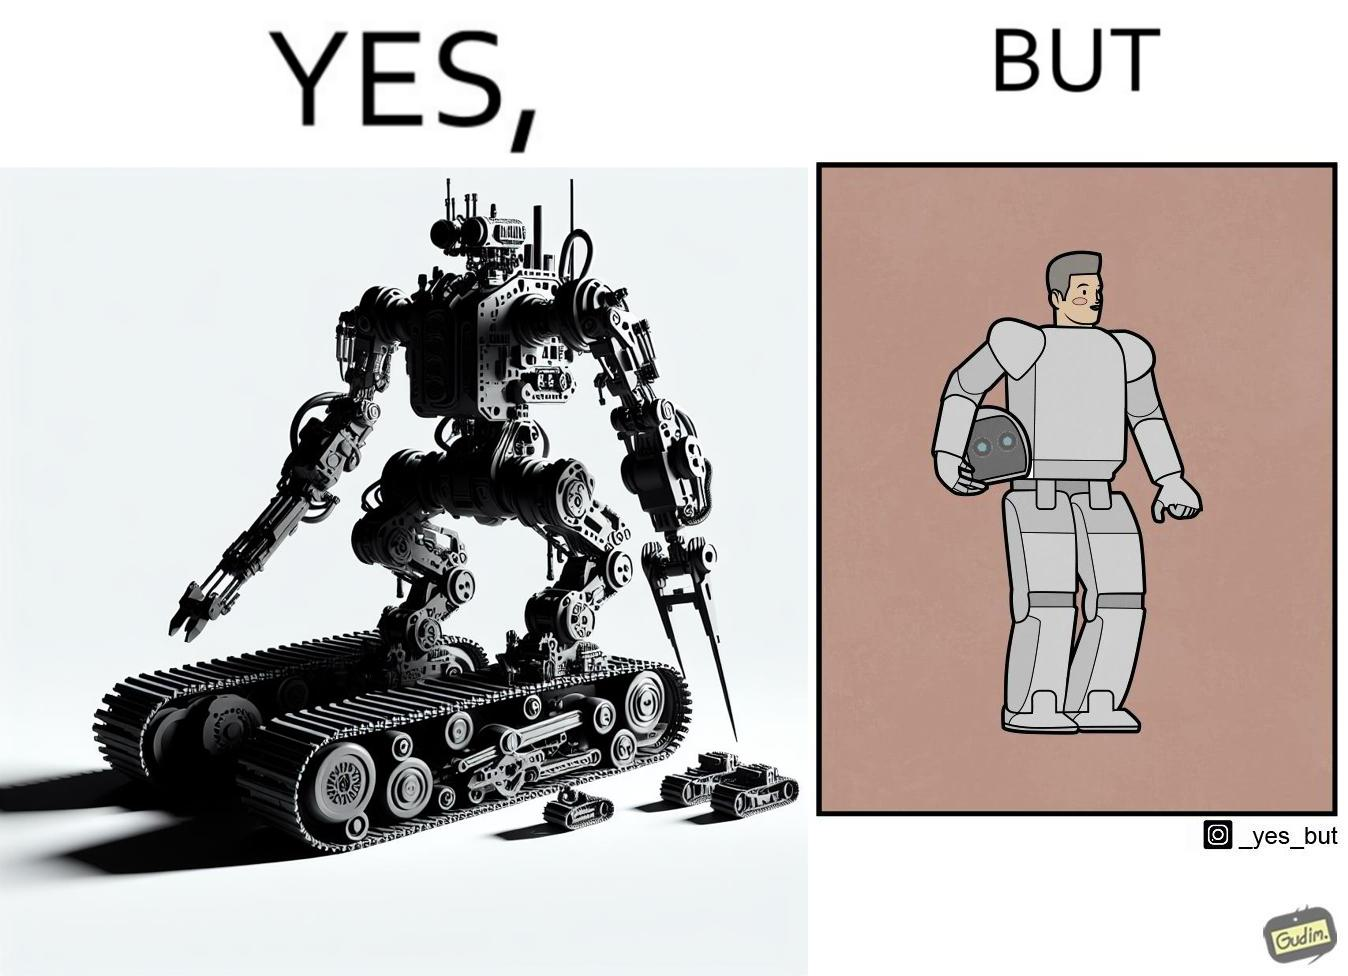Describe what you see in this image. The images are ironic since we work to improve technology and build innovations like robots, but in the process we ourselves become less human and robotic in the way we function. 